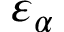<formula> <loc_0><loc_0><loc_500><loc_500>\varepsilon _ { \alpha }</formula> 